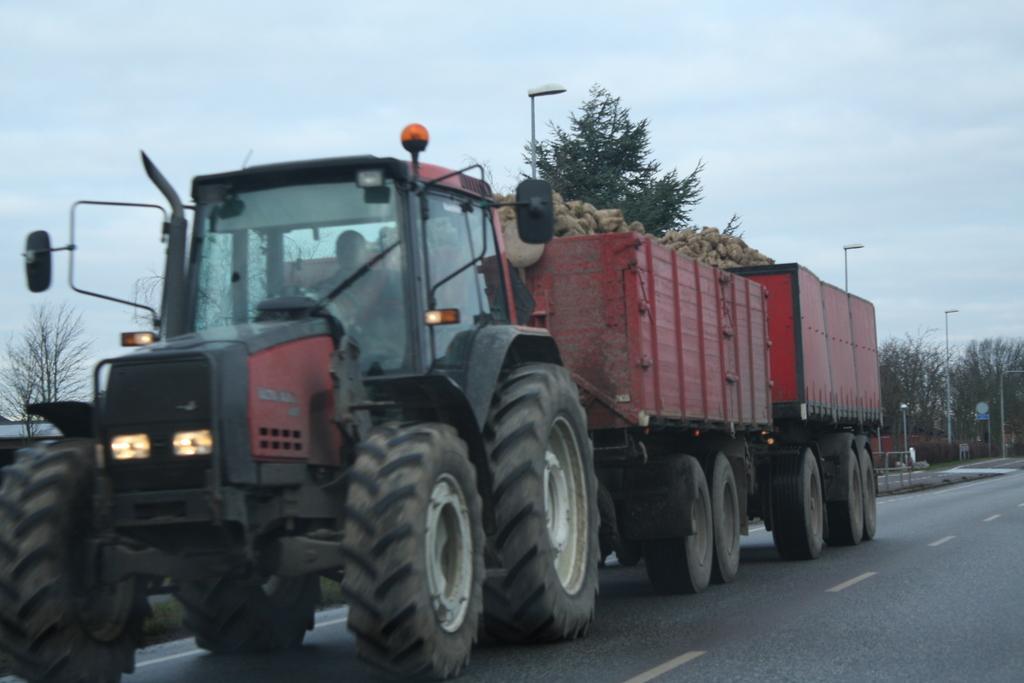Can you describe this image briefly? Here we can see a person riding vehicle on the road and in the container we can see some items. In the background we can see trees,street lights,sign board poles and clouds in the sky. 